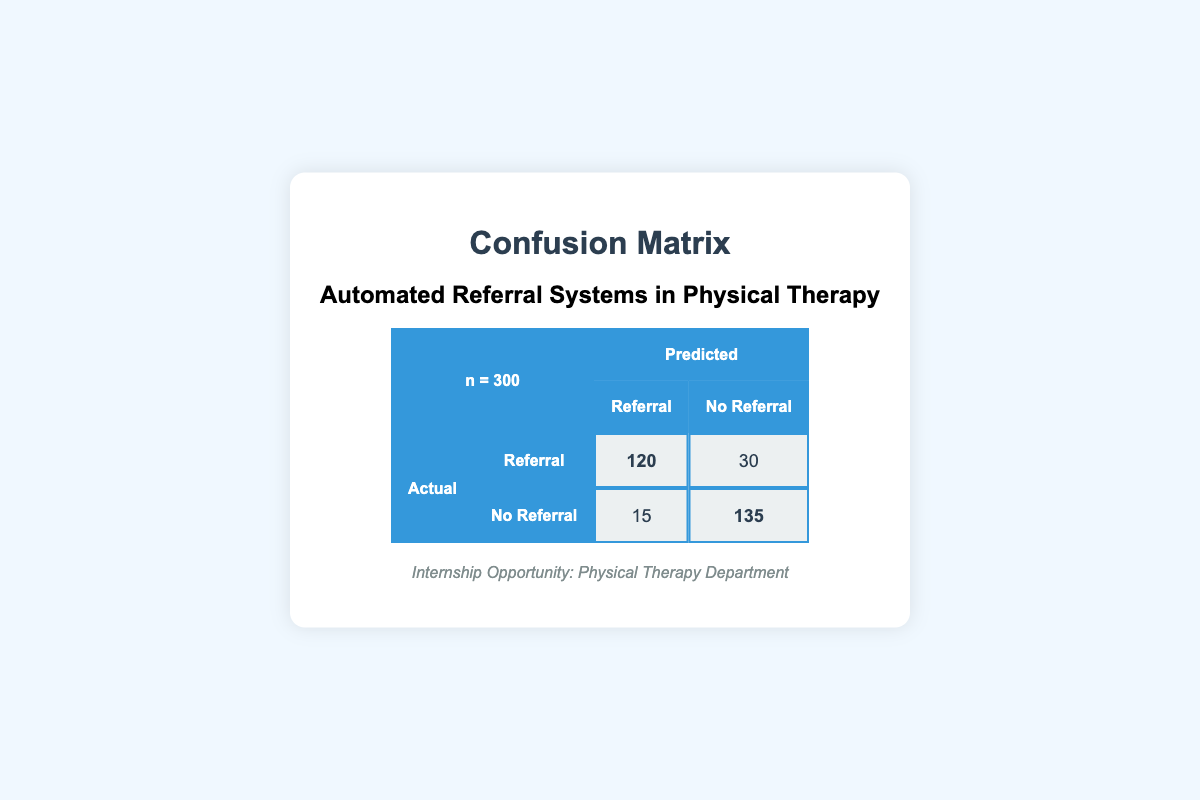What is the total number of actual referrals? In the confusion matrix, we see that "Actual Referral" has a count of 120. This directly indicates the total number of actual referrals in this dataset.
Answer: 120 What is the total number of actual no referrals? In the confusion matrix, the "Actual No Referral" row has a count of 135. This number represents the total actual no referrals in this dataset.
Answer: 135 How many referrals were incorrectly predicted as no referrals? The confusion matrix indicates that there were 30 cases of actual referrals that were incorrectly predicted as no referrals. This value is taken from the row "Actual Referral" and column "No Referral."
Answer: 30 What is the total number of predictions made by the automated referral system? To find the total number of predictions, we add all the values in the confusion matrix: 120 (Referral, Referral) + 30 (Referral, No Referral) + 15 (No Referral, Referral) + 135 (No Referral, No Referral) = 300. Thus, the total number of predictions is 300.
Answer: 300 What percentage of actual referrals were predicted correctly? To calculate the percentage of actual referrals predicted correctly, divide the number of correctly predicted referrals (120) by the total number of actual referrals (120 + 30 = 150). Thus, (120 / 150) * 100 = 80%.
Answer: 80% Are there more actual referrals than no referrals? The confusion matrix shows that there are 120 actual referrals and 135 actual no referrals. Since 120 is less than 135, the statement is false.
Answer: No What is the sum of predictions for no referrals? The sum of predictions for no referrals can be found by adding the corresponding values from the confusion matrix: 30 (Referral, No Referral) + 135 (No Referral, No Referral) = 165.
Answer: 165 What is the number of cases where no referral was incorrectly predicted as a referral? According to the confusion matrix, there were 15 cases where no referral was incorrectly predicted as a referral. This value is found in the row "Actual No Referral" and column "Referral."
Answer: 15 What is the total number of actual cases in the confusion matrix? To find the total number of actual cases, we add the total actual referrals (120) and total actual no referrals (135). Therefore, 120 + 135 = 255.
Answer: 255 